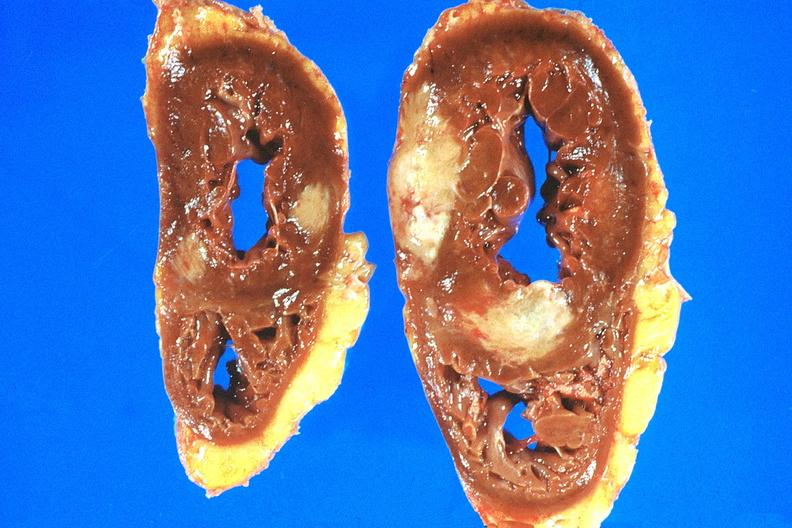s cardiovascular present?
Answer the question using a single word or phrase. Yes 